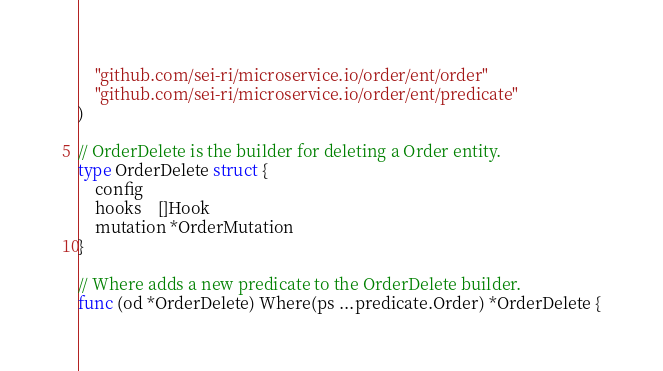Convert code to text. <code><loc_0><loc_0><loc_500><loc_500><_Go_>	"github.com/sei-ri/microservice.io/order/ent/order"
	"github.com/sei-ri/microservice.io/order/ent/predicate"
)

// OrderDelete is the builder for deleting a Order entity.
type OrderDelete struct {
	config
	hooks    []Hook
	mutation *OrderMutation
}

// Where adds a new predicate to the OrderDelete builder.
func (od *OrderDelete) Where(ps ...predicate.Order) *OrderDelete {</code> 